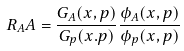<formula> <loc_0><loc_0><loc_500><loc_500>R _ { A } A = \frac { G _ { A } ( x , p ) } { G _ { p } ( x . p ) } \frac { \phi _ { A } ( x , p ) } { \phi _ { p } ( x , p ) }</formula> 